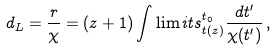<formula> <loc_0><loc_0><loc_500><loc_500>d _ { L } = \frac { r } { \chi } = ( z + 1 ) \int \lim i t s _ { t ( z ) } ^ { t _ { 0 } } \frac { d t ^ { \prime } } { \chi ( t ^ { \prime } ) } \, ,</formula> 